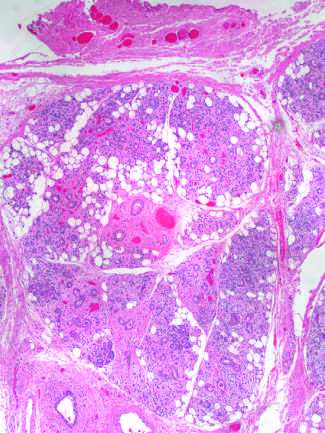s bile duct cells and canals of hering produced by radiation therapy of the neck region?
Answer the question using a single word or phrase. No 